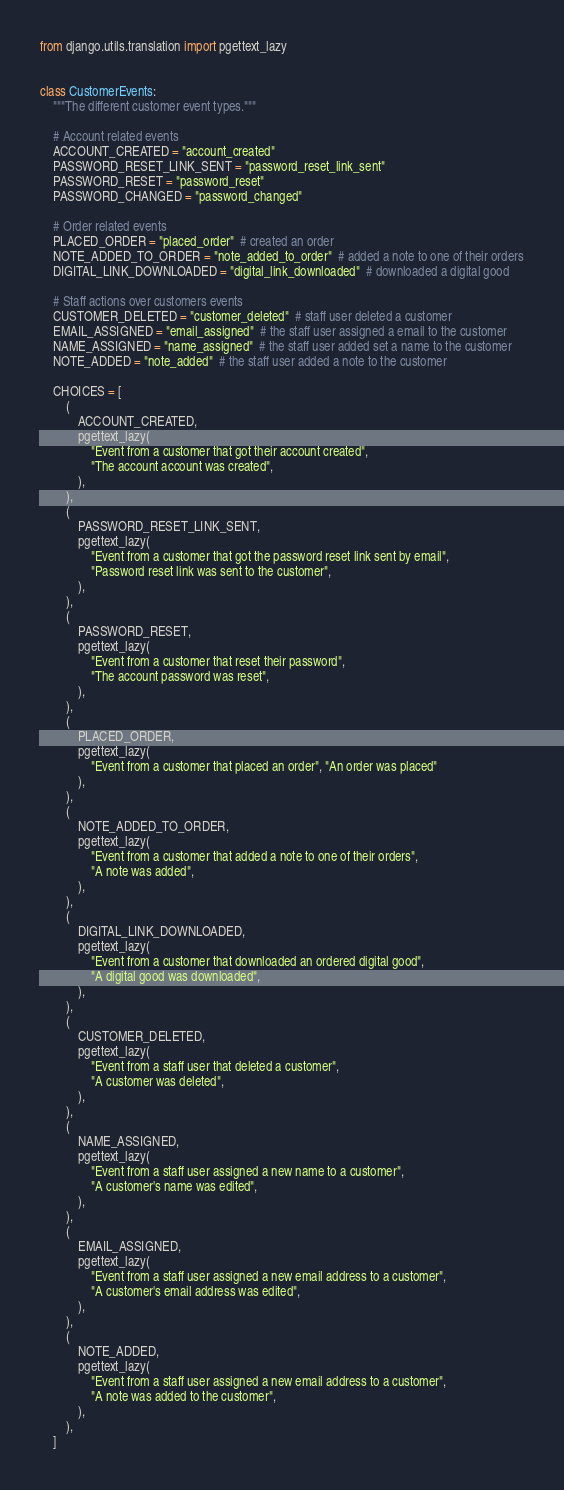<code> <loc_0><loc_0><loc_500><loc_500><_Python_>from django.utils.translation import pgettext_lazy


class CustomerEvents:
    """The different customer event types."""

    # Account related events
    ACCOUNT_CREATED = "account_created"
    PASSWORD_RESET_LINK_SENT = "password_reset_link_sent"
    PASSWORD_RESET = "password_reset"
    PASSWORD_CHANGED = "password_changed"

    # Order related events
    PLACED_ORDER = "placed_order"  # created an order
    NOTE_ADDED_TO_ORDER = "note_added_to_order"  # added a note to one of their orders
    DIGITAL_LINK_DOWNLOADED = "digital_link_downloaded"  # downloaded a digital good

    # Staff actions over customers events
    CUSTOMER_DELETED = "customer_deleted"  # staff user deleted a customer
    EMAIL_ASSIGNED = "email_assigned"  # the staff user assigned a email to the customer
    NAME_ASSIGNED = "name_assigned"  # the staff user added set a name to the customer
    NOTE_ADDED = "note_added"  # the staff user added a note to the customer

    CHOICES = [
        (
            ACCOUNT_CREATED,
            pgettext_lazy(
                "Event from a customer that got their account created",
                "The account account was created",
            ),
        ),
        (
            PASSWORD_RESET_LINK_SENT,
            pgettext_lazy(
                "Event from a customer that got the password reset link sent by email",
                "Password reset link was sent to the customer",
            ),
        ),
        (
            PASSWORD_RESET,
            pgettext_lazy(
                "Event from a customer that reset their password",
                "The account password was reset",
            ),
        ),
        (
            PLACED_ORDER,
            pgettext_lazy(
                "Event from a customer that placed an order", "An order was placed"
            ),
        ),
        (
            NOTE_ADDED_TO_ORDER,
            pgettext_lazy(
                "Event from a customer that added a note to one of their orders",
                "A note was added",
            ),
        ),
        (
            DIGITAL_LINK_DOWNLOADED,
            pgettext_lazy(
                "Event from a customer that downloaded an ordered digital good",
                "A digital good was downloaded",
            ),
        ),
        (
            CUSTOMER_DELETED,
            pgettext_lazy(
                "Event from a staff user that deleted a customer",
                "A customer was deleted",
            ),
        ),
        (
            NAME_ASSIGNED,
            pgettext_lazy(
                "Event from a staff user assigned a new name to a customer",
                "A customer's name was edited",
            ),
        ),
        (
            EMAIL_ASSIGNED,
            pgettext_lazy(
                "Event from a staff user assigned a new email address to a customer",
                "A customer's email address was edited",
            ),
        ),
        (
            NOTE_ADDED,
            pgettext_lazy(
                "Event from a staff user assigned a new email address to a customer",
                "A note was added to the customer",
            ),
        ),
    ]
</code> 